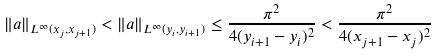<formula> <loc_0><loc_0><loc_500><loc_500>\| a \| _ { L ^ { \infty } ( x _ { j } , x _ { j + 1 } ) } < \| a \| _ { L ^ { \infty } ( y _ { i } , y _ { i + 1 } ) } \leq \frac { \pi ^ { 2 } } { 4 ( y _ { i + 1 } - y _ { i } ) ^ { 2 } } < \frac { \pi ^ { 2 } } { 4 ( x _ { j + 1 } - x _ { j } ) ^ { 2 } }</formula> 